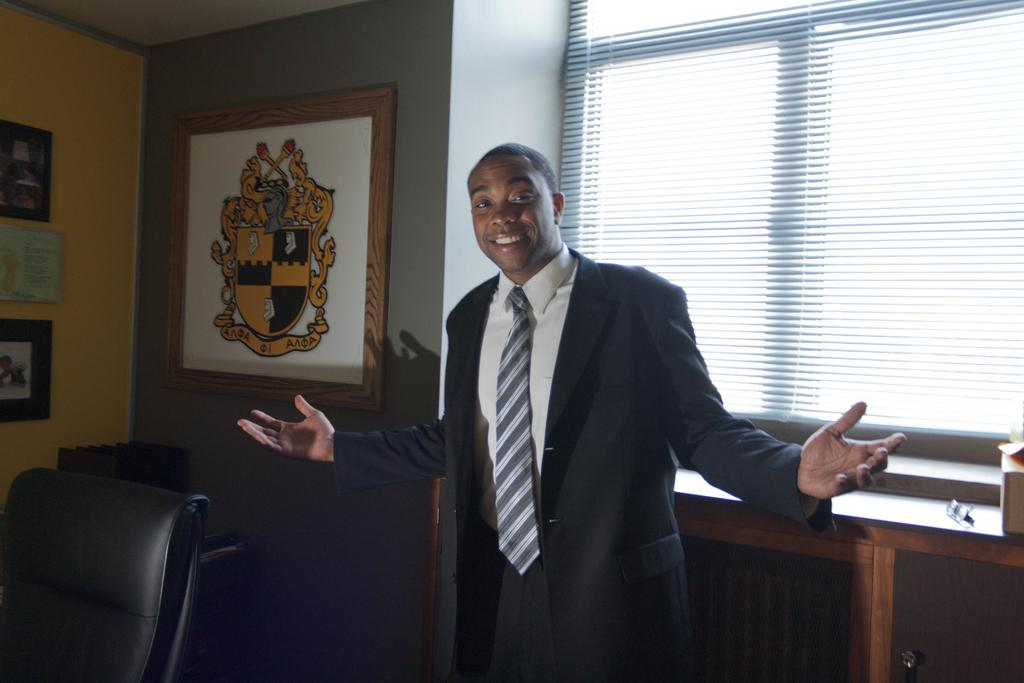What is the man in the image doing? The man is standing in the image and smiling. What can be seen on the left side of the image? There is a chair on the left side of the image. How many frames are on the wall in the image? There are four frames on the wall. What is located behind the man in the image? There is a window behind the man. What type of bulb is the man holding in the image? There is no bulb present in the image. 